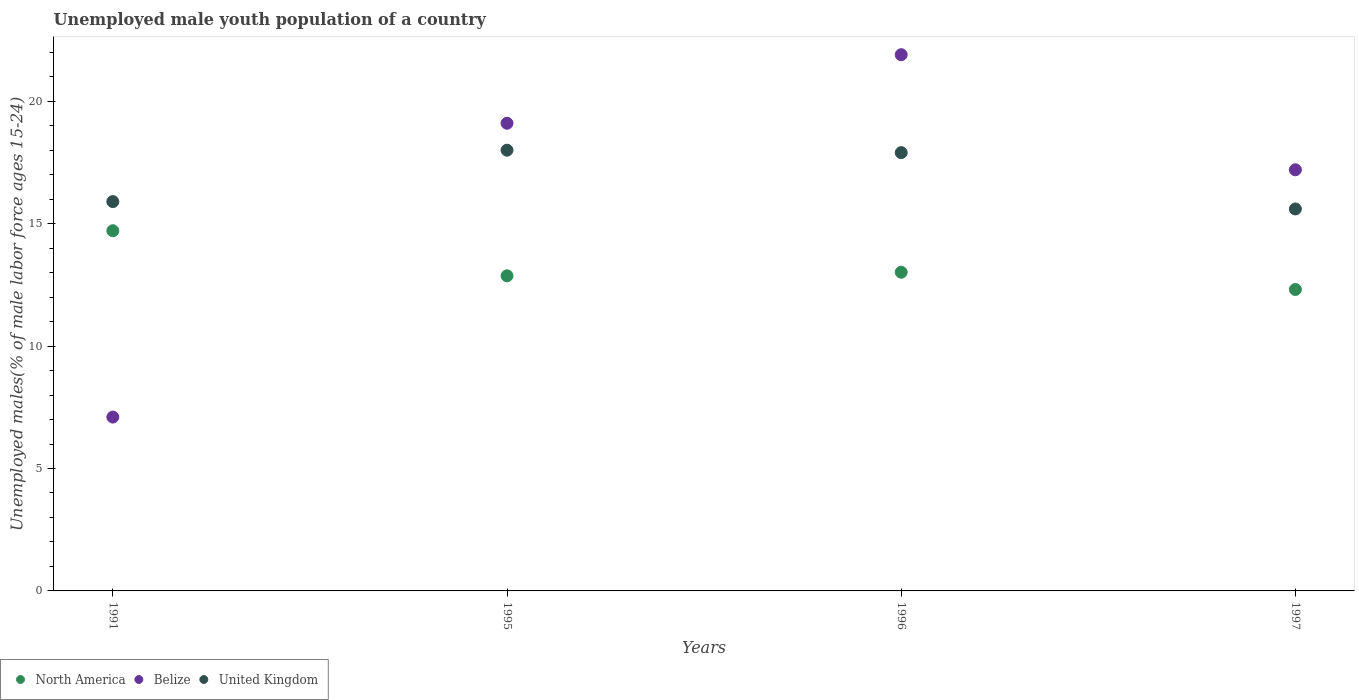Is the number of dotlines equal to the number of legend labels?
Offer a terse response. Yes. What is the percentage of unemployed male youth population in North America in 1991?
Provide a short and direct response. 14.71. Across all years, what is the maximum percentage of unemployed male youth population in Belize?
Your answer should be compact. 21.9. Across all years, what is the minimum percentage of unemployed male youth population in North America?
Offer a terse response. 12.31. In which year was the percentage of unemployed male youth population in United Kingdom maximum?
Offer a terse response. 1995. In which year was the percentage of unemployed male youth population in Belize minimum?
Ensure brevity in your answer.  1991. What is the total percentage of unemployed male youth population in Belize in the graph?
Your answer should be compact. 65.3. What is the difference between the percentage of unemployed male youth population in North America in 1991 and that in 1996?
Your response must be concise. 1.7. What is the difference between the percentage of unemployed male youth population in North America in 1995 and the percentage of unemployed male youth population in United Kingdom in 1996?
Provide a short and direct response. -5.03. What is the average percentage of unemployed male youth population in United Kingdom per year?
Make the answer very short. 16.85. In the year 1997, what is the difference between the percentage of unemployed male youth population in Belize and percentage of unemployed male youth population in United Kingdom?
Ensure brevity in your answer.  1.6. What is the ratio of the percentage of unemployed male youth population in United Kingdom in 1991 to that in 1996?
Offer a very short reply. 0.89. What is the difference between the highest and the second highest percentage of unemployed male youth population in Belize?
Your response must be concise. 2.8. What is the difference between the highest and the lowest percentage of unemployed male youth population in United Kingdom?
Provide a short and direct response. 2.4. Is the sum of the percentage of unemployed male youth population in Belize in 1991 and 1996 greater than the maximum percentage of unemployed male youth population in United Kingdom across all years?
Ensure brevity in your answer.  Yes. Is it the case that in every year, the sum of the percentage of unemployed male youth population in Belize and percentage of unemployed male youth population in United Kingdom  is greater than the percentage of unemployed male youth population in North America?
Your response must be concise. Yes. Is the percentage of unemployed male youth population in North America strictly less than the percentage of unemployed male youth population in United Kingdom over the years?
Your answer should be very brief. Yes. How many years are there in the graph?
Ensure brevity in your answer.  4. What is the difference between two consecutive major ticks on the Y-axis?
Keep it short and to the point. 5. Does the graph contain any zero values?
Offer a terse response. No. What is the title of the graph?
Provide a succinct answer. Unemployed male youth population of a country. Does "Liberia" appear as one of the legend labels in the graph?
Offer a terse response. No. What is the label or title of the Y-axis?
Provide a short and direct response. Unemployed males(% of male labor force ages 15-24). What is the Unemployed males(% of male labor force ages 15-24) in North America in 1991?
Give a very brief answer. 14.71. What is the Unemployed males(% of male labor force ages 15-24) of Belize in 1991?
Offer a terse response. 7.1. What is the Unemployed males(% of male labor force ages 15-24) of United Kingdom in 1991?
Provide a succinct answer. 15.9. What is the Unemployed males(% of male labor force ages 15-24) in North America in 1995?
Provide a succinct answer. 12.87. What is the Unemployed males(% of male labor force ages 15-24) in Belize in 1995?
Make the answer very short. 19.1. What is the Unemployed males(% of male labor force ages 15-24) in United Kingdom in 1995?
Give a very brief answer. 18. What is the Unemployed males(% of male labor force ages 15-24) in North America in 1996?
Provide a short and direct response. 13.02. What is the Unemployed males(% of male labor force ages 15-24) in Belize in 1996?
Your answer should be very brief. 21.9. What is the Unemployed males(% of male labor force ages 15-24) in United Kingdom in 1996?
Your answer should be compact. 17.9. What is the Unemployed males(% of male labor force ages 15-24) in North America in 1997?
Provide a succinct answer. 12.31. What is the Unemployed males(% of male labor force ages 15-24) in Belize in 1997?
Keep it short and to the point. 17.2. What is the Unemployed males(% of male labor force ages 15-24) in United Kingdom in 1997?
Offer a terse response. 15.6. Across all years, what is the maximum Unemployed males(% of male labor force ages 15-24) in North America?
Your answer should be very brief. 14.71. Across all years, what is the maximum Unemployed males(% of male labor force ages 15-24) of Belize?
Keep it short and to the point. 21.9. Across all years, what is the minimum Unemployed males(% of male labor force ages 15-24) in North America?
Ensure brevity in your answer.  12.31. Across all years, what is the minimum Unemployed males(% of male labor force ages 15-24) in Belize?
Your answer should be compact. 7.1. Across all years, what is the minimum Unemployed males(% of male labor force ages 15-24) in United Kingdom?
Your answer should be very brief. 15.6. What is the total Unemployed males(% of male labor force ages 15-24) in North America in the graph?
Ensure brevity in your answer.  52.91. What is the total Unemployed males(% of male labor force ages 15-24) of Belize in the graph?
Your answer should be compact. 65.3. What is the total Unemployed males(% of male labor force ages 15-24) of United Kingdom in the graph?
Offer a terse response. 67.4. What is the difference between the Unemployed males(% of male labor force ages 15-24) of North America in 1991 and that in 1995?
Provide a short and direct response. 1.84. What is the difference between the Unemployed males(% of male labor force ages 15-24) of Belize in 1991 and that in 1995?
Keep it short and to the point. -12. What is the difference between the Unemployed males(% of male labor force ages 15-24) in United Kingdom in 1991 and that in 1995?
Provide a succinct answer. -2.1. What is the difference between the Unemployed males(% of male labor force ages 15-24) of North America in 1991 and that in 1996?
Offer a very short reply. 1.7. What is the difference between the Unemployed males(% of male labor force ages 15-24) in Belize in 1991 and that in 1996?
Provide a succinct answer. -14.8. What is the difference between the Unemployed males(% of male labor force ages 15-24) of United Kingdom in 1991 and that in 1996?
Give a very brief answer. -2. What is the difference between the Unemployed males(% of male labor force ages 15-24) of North America in 1991 and that in 1997?
Offer a terse response. 2.4. What is the difference between the Unemployed males(% of male labor force ages 15-24) of United Kingdom in 1991 and that in 1997?
Provide a succinct answer. 0.3. What is the difference between the Unemployed males(% of male labor force ages 15-24) of North America in 1995 and that in 1996?
Ensure brevity in your answer.  -0.15. What is the difference between the Unemployed males(% of male labor force ages 15-24) of North America in 1995 and that in 1997?
Ensure brevity in your answer.  0.56. What is the difference between the Unemployed males(% of male labor force ages 15-24) of Belize in 1995 and that in 1997?
Your response must be concise. 1.9. What is the difference between the Unemployed males(% of male labor force ages 15-24) in United Kingdom in 1995 and that in 1997?
Offer a very short reply. 2.4. What is the difference between the Unemployed males(% of male labor force ages 15-24) in North America in 1996 and that in 1997?
Keep it short and to the point. 0.71. What is the difference between the Unemployed males(% of male labor force ages 15-24) in Belize in 1996 and that in 1997?
Keep it short and to the point. 4.7. What is the difference between the Unemployed males(% of male labor force ages 15-24) of United Kingdom in 1996 and that in 1997?
Keep it short and to the point. 2.3. What is the difference between the Unemployed males(% of male labor force ages 15-24) of North America in 1991 and the Unemployed males(% of male labor force ages 15-24) of Belize in 1995?
Offer a terse response. -4.39. What is the difference between the Unemployed males(% of male labor force ages 15-24) in North America in 1991 and the Unemployed males(% of male labor force ages 15-24) in United Kingdom in 1995?
Provide a succinct answer. -3.29. What is the difference between the Unemployed males(% of male labor force ages 15-24) of Belize in 1991 and the Unemployed males(% of male labor force ages 15-24) of United Kingdom in 1995?
Offer a very short reply. -10.9. What is the difference between the Unemployed males(% of male labor force ages 15-24) of North America in 1991 and the Unemployed males(% of male labor force ages 15-24) of Belize in 1996?
Your answer should be very brief. -7.19. What is the difference between the Unemployed males(% of male labor force ages 15-24) of North America in 1991 and the Unemployed males(% of male labor force ages 15-24) of United Kingdom in 1996?
Give a very brief answer. -3.19. What is the difference between the Unemployed males(% of male labor force ages 15-24) in North America in 1991 and the Unemployed males(% of male labor force ages 15-24) in Belize in 1997?
Offer a very short reply. -2.49. What is the difference between the Unemployed males(% of male labor force ages 15-24) in North America in 1991 and the Unemployed males(% of male labor force ages 15-24) in United Kingdom in 1997?
Give a very brief answer. -0.89. What is the difference between the Unemployed males(% of male labor force ages 15-24) in North America in 1995 and the Unemployed males(% of male labor force ages 15-24) in Belize in 1996?
Provide a succinct answer. -9.03. What is the difference between the Unemployed males(% of male labor force ages 15-24) in North America in 1995 and the Unemployed males(% of male labor force ages 15-24) in United Kingdom in 1996?
Make the answer very short. -5.03. What is the difference between the Unemployed males(% of male labor force ages 15-24) in Belize in 1995 and the Unemployed males(% of male labor force ages 15-24) in United Kingdom in 1996?
Offer a very short reply. 1.2. What is the difference between the Unemployed males(% of male labor force ages 15-24) of North America in 1995 and the Unemployed males(% of male labor force ages 15-24) of Belize in 1997?
Offer a terse response. -4.33. What is the difference between the Unemployed males(% of male labor force ages 15-24) of North America in 1995 and the Unemployed males(% of male labor force ages 15-24) of United Kingdom in 1997?
Make the answer very short. -2.73. What is the difference between the Unemployed males(% of male labor force ages 15-24) of Belize in 1995 and the Unemployed males(% of male labor force ages 15-24) of United Kingdom in 1997?
Offer a terse response. 3.5. What is the difference between the Unemployed males(% of male labor force ages 15-24) in North America in 1996 and the Unemployed males(% of male labor force ages 15-24) in Belize in 1997?
Your answer should be very brief. -4.18. What is the difference between the Unemployed males(% of male labor force ages 15-24) in North America in 1996 and the Unemployed males(% of male labor force ages 15-24) in United Kingdom in 1997?
Give a very brief answer. -2.58. What is the difference between the Unemployed males(% of male labor force ages 15-24) of Belize in 1996 and the Unemployed males(% of male labor force ages 15-24) of United Kingdom in 1997?
Offer a terse response. 6.3. What is the average Unemployed males(% of male labor force ages 15-24) in North America per year?
Give a very brief answer. 13.23. What is the average Unemployed males(% of male labor force ages 15-24) in Belize per year?
Offer a very short reply. 16.32. What is the average Unemployed males(% of male labor force ages 15-24) in United Kingdom per year?
Your response must be concise. 16.85. In the year 1991, what is the difference between the Unemployed males(% of male labor force ages 15-24) of North America and Unemployed males(% of male labor force ages 15-24) of Belize?
Your answer should be very brief. 7.61. In the year 1991, what is the difference between the Unemployed males(% of male labor force ages 15-24) of North America and Unemployed males(% of male labor force ages 15-24) of United Kingdom?
Your answer should be very brief. -1.19. In the year 1991, what is the difference between the Unemployed males(% of male labor force ages 15-24) in Belize and Unemployed males(% of male labor force ages 15-24) in United Kingdom?
Make the answer very short. -8.8. In the year 1995, what is the difference between the Unemployed males(% of male labor force ages 15-24) of North America and Unemployed males(% of male labor force ages 15-24) of Belize?
Your response must be concise. -6.23. In the year 1995, what is the difference between the Unemployed males(% of male labor force ages 15-24) of North America and Unemployed males(% of male labor force ages 15-24) of United Kingdom?
Your response must be concise. -5.13. In the year 1995, what is the difference between the Unemployed males(% of male labor force ages 15-24) of Belize and Unemployed males(% of male labor force ages 15-24) of United Kingdom?
Provide a succinct answer. 1.1. In the year 1996, what is the difference between the Unemployed males(% of male labor force ages 15-24) in North America and Unemployed males(% of male labor force ages 15-24) in Belize?
Ensure brevity in your answer.  -8.88. In the year 1996, what is the difference between the Unemployed males(% of male labor force ages 15-24) in North America and Unemployed males(% of male labor force ages 15-24) in United Kingdom?
Offer a very short reply. -4.88. In the year 1997, what is the difference between the Unemployed males(% of male labor force ages 15-24) of North America and Unemployed males(% of male labor force ages 15-24) of Belize?
Your answer should be very brief. -4.89. In the year 1997, what is the difference between the Unemployed males(% of male labor force ages 15-24) of North America and Unemployed males(% of male labor force ages 15-24) of United Kingdom?
Your response must be concise. -3.29. What is the ratio of the Unemployed males(% of male labor force ages 15-24) of North America in 1991 to that in 1995?
Provide a short and direct response. 1.14. What is the ratio of the Unemployed males(% of male labor force ages 15-24) in Belize in 1991 to that in 1995?
Provide a succinct answer. 0.37. What is the ratio of the Unemployed males(% of male labor force ages 15-24) in United Kingdom in 1991 to that in 1995?
Provide a short and direct response. 0.88. What is the ratio of the Unemployed males(% of male labor force ages 15-24) in North America in 1991 to that in 1996?
Ensure brevity in your answer.  1.13. What is the ratio of the Unemployed males(% of male labor force ages 15-24) in Belize in 1991 to that in 1996?
Your response must be concise. 0.32. What is the ratio of the Unemployed males(% of male labor force ages 15-24) of United Kingdom in 1991 to that in 1996?
Keep it short and to the point. 0.89. What is the ratio of the Unemployed males(% of male labor force ages 15-24) in North America in 1991 to that in 1997?
Offer a very short reply. 1.2. What is the ratio of the Unemployed males(% of male labor force ages 15-24) of Belize in 1991 to that in 1997?
Give a very brief answer. 0.41. What is the ratio of the Unemployed males(% of male labor force ages 15-24) in United Kingdom in 1991 to that in 1997?
Give a very brief answer. 1.02. What is the ratio of the Unemployed males(% of male labor force ages 15-24) of North America in 1995 to that in 1996?
Your answer should be compact. 0.99. What is the ratio of the Unemployed males(% of male labor force ages 15-24) in Belize in 1995 to that in 1996?
Offer a very short reply. 0.87. What is the ratio of the Unemployed males(% of male labor force ages 15-24) in United Kingdom in 1995 to that in 1996?
Your response must be concise. 1.01. What is the ratio of the Unemployed males(% of male labor force ages 15-24) of North America in 1995 to that in 1997?
Offer a terse response. 1.05. What is the ratio of the Unemployed males(% of male labor force ages 15-24) in Belize in 1995 to that in 1997?
Your answer should be very brief. 1.11. What is the ratio of the Unemployed males(% of male labor force ages 15-24) of United Kingdom in 1995 to that in 1997?
Provide a short and direct response. 1.15. What is the ratio of the Unemployed males(% of male labor force ages 15-24) of North America in 1996 to that in 1997?
Provide a succinct answer. 1.06. What is the ratio of the Unemployed males(% of male labor force ages 15-24) of Belize in 1996 to that in 1997?
Your answer should be compact. 1.27. What is the ratio of the Unemployed males(% of male labor force ages 15-24) of United Kingdom in 1996 to that in 1997?
Offer a terse response. 1.15. What is the difference between the highest and the second highest Unemployed males(% of male labor force ages 15-24) of North America?
Provide a succinct answer. 1.7. What is the difference between the highest and the second highest Unemployed males(% of male labor force ages 15-24) in Belize?
Offer a very short reply. 2.8. What is the difference between the highest and the lowest Unemployed males(% of male labor force ages 15-24) of North America?
Provide a short and direct response. 2.4. What is the difference between the highest and the lowest Unemployed males(% of male labor force ages 15-24) of Belize?
Ensure brevity in your answer.  14.8. What is the difference between the highest and the lowest Unemployed males(% of male labor force ages 15-24) in United Kingdom?
Ensure brevity in your answer.  2.4. 